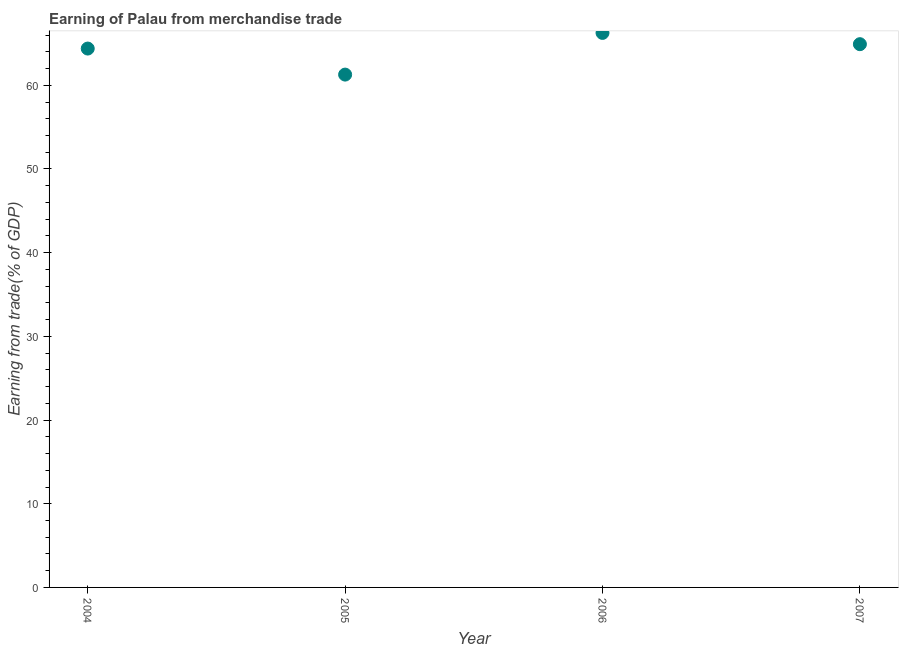What is the earning from merchandise trade in 2005?
Make the answer very short. 61.28. Across all years, what is the maximum earning from merchandise trade?
Your answer should be very brief. 66.26. Across all years, what is the minimum earning from merchandise trade?
Keep it short and to the point. 61.28. What is the sum of the earning from merchandise trade?
Ensure brevity in your answer.  256.85. What is the difference between the earning from merchandise trade in 2005 and 2006?
Your answer should be compact. -4.98. What is the average earning from merchandise trade per year?
Give a very brief answer. 64.21. What is the median earning from merchandise trade?
Give a very brief answer. 64.65. What is the ratio of the earning from merchandise trade in 2004 to that in 2006?
Provide a short and direct response. 0.97. What is the difference between the highest and the second highest earning from merchandise trade?
Your answer should be very brief. 1.35. What is the difference between the highest and the lowest earning from merchandise trade?
Provide a short and direct response. 4.98. How many years are there in the graph?
Your answer should be very brief. 4. What is the difference between two consecutive major ticks on the Y-axis?
Make the answer very short. 10. Are the values on the major ticks of Y-axis written in scientific E-notation?
Offer a terse response. No. Does the graph contain any zero values?
Keep it short and to the point. No. What is the title of the graph?
Give a very brief answer. Earning of Palau from merchandise trade. What is the label or title of the X-axis?
Provide a short and direct response. Year. What is the label or title of the Y-axis?
Provide a succinct answer. Earning from trade(% of GDP). What is the Earning from trade(% of GDP) in 2004?
Your response must be concise. 64.39. What is the Earning from trade(% of GDP) in 2005?
Your response must be concise. 61.28. What is the Earning from trade(% of GDP) in 2006?
Provide a succinct answer. 66.26. What is the Earning from trade(% of GDP) in 2007?
Your response must be concise. 64.91. What is the difference between the Earning from trade(% of GDP) in 2004 and 2005?
Provide a short and direct response. 3.11. What is the difference between the Earning from trade(% of GDP) in 2004 and 2006?
Keep it short and to the point. -1.87. What is the difference between the Earning from trade(% of GDP) in 2004 and 2007?
Your answer should be very brief. -0.52. What is the difference between the Earning from trade(% of GDP) in 2005 and 2006?
Ensure brevity in your answer.  -4.98. What is the difference between the Earning from trade(% of GDP) in 2005 and 2007?
Make the answer very short. -3.63. What is the difference between the Earning from trade(% of GDP) in 2006 and 2007?
Give a very brief answer. 1.35. What is the ratio of the Earning from trade(% of GDP) in 2004 to that in 2005?
Your response must be concise. 1.05. What is the ratio of the Earning from trade(% of GDP) in 2004 to that in 2006?
Your answer should be very brief. 0.97. What is the ratio of the Earning from trade(% of GDP) in 2005 to that in 2006?
Ensure brevity in your answer.  0.93. What is the ratio of the Earning from trade(% of GDP) in 2005 to that in 2007?
Your answer should be compact. 0.94. 